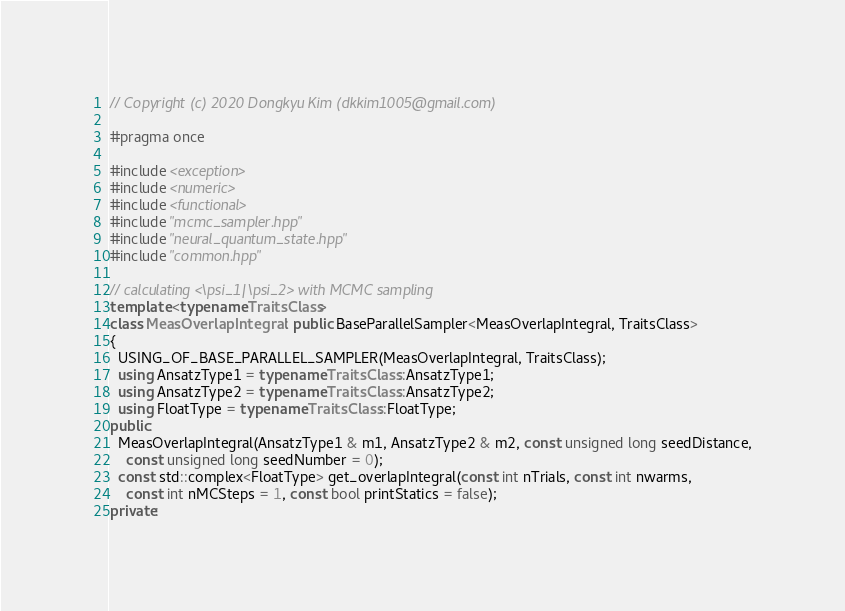<code> <loc_0><loc_0><loc_500><loc_500><_C++_>// Copyright (c) 2020 Dongkyu Kim (dkkim1005@gmail.com)

#pragma once

#include <exception>
#include <numeric>
#include <functional>
#include "mcmc_sampler.hpp"
#include "neural_quantum_state.hpp"
#include "common.hpp"

// calculating <\psi_1|\psi_2> with MCMC sampling
template <typename TraitsClass>
class MeasOverlapIntegral : public BaseParallelSampler<MeasOverlapIntegral, TraitsClass>
{
  USING_OF_BASE_PARALLEL_SAMPLER(MeasOverlapIntegral, TraitsClass);
  using AnsatzType1 = typename TraitsClass::AnsatzType1;
  using AnsatzType2 = typename TraitsClass::AnsatzType2;
  using FloatType = typename TraitsClass::FloatType;
public:
  MeasOverlapIntegral(AnsatzType1 & m1, AnsatzType2 & m2, const unsigned long seedDistance,
    const unsigned long seedNumber = 0);
  const std::complex<FloatType> get_overlapIntegral(const int nTrials, const int nwarms,
    const int nMCSteps = 1, const bool printStatics = false);
private:</code> 